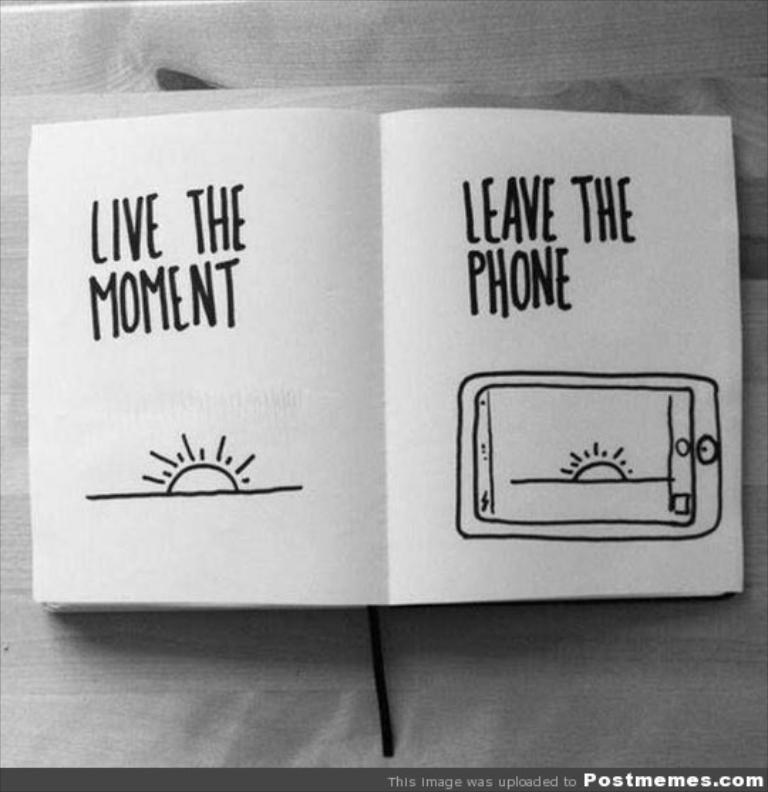<image>
Write a terse but informative summary of the picture. A paper that says Live the Moment and Leave the Phone. 